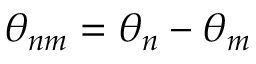Convert formula to latex. <formula><loc_0><loc_0><loc_500><loc_500>\theta _ { n m } = \theta _ { n } - \theta _ { m }</formula> 